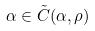Convert formula to latex. <formula><loc_0><loc_0><loc_500><loc_500>\alpha \in \tilde { C } ( \alpha , \rho )</formula> 